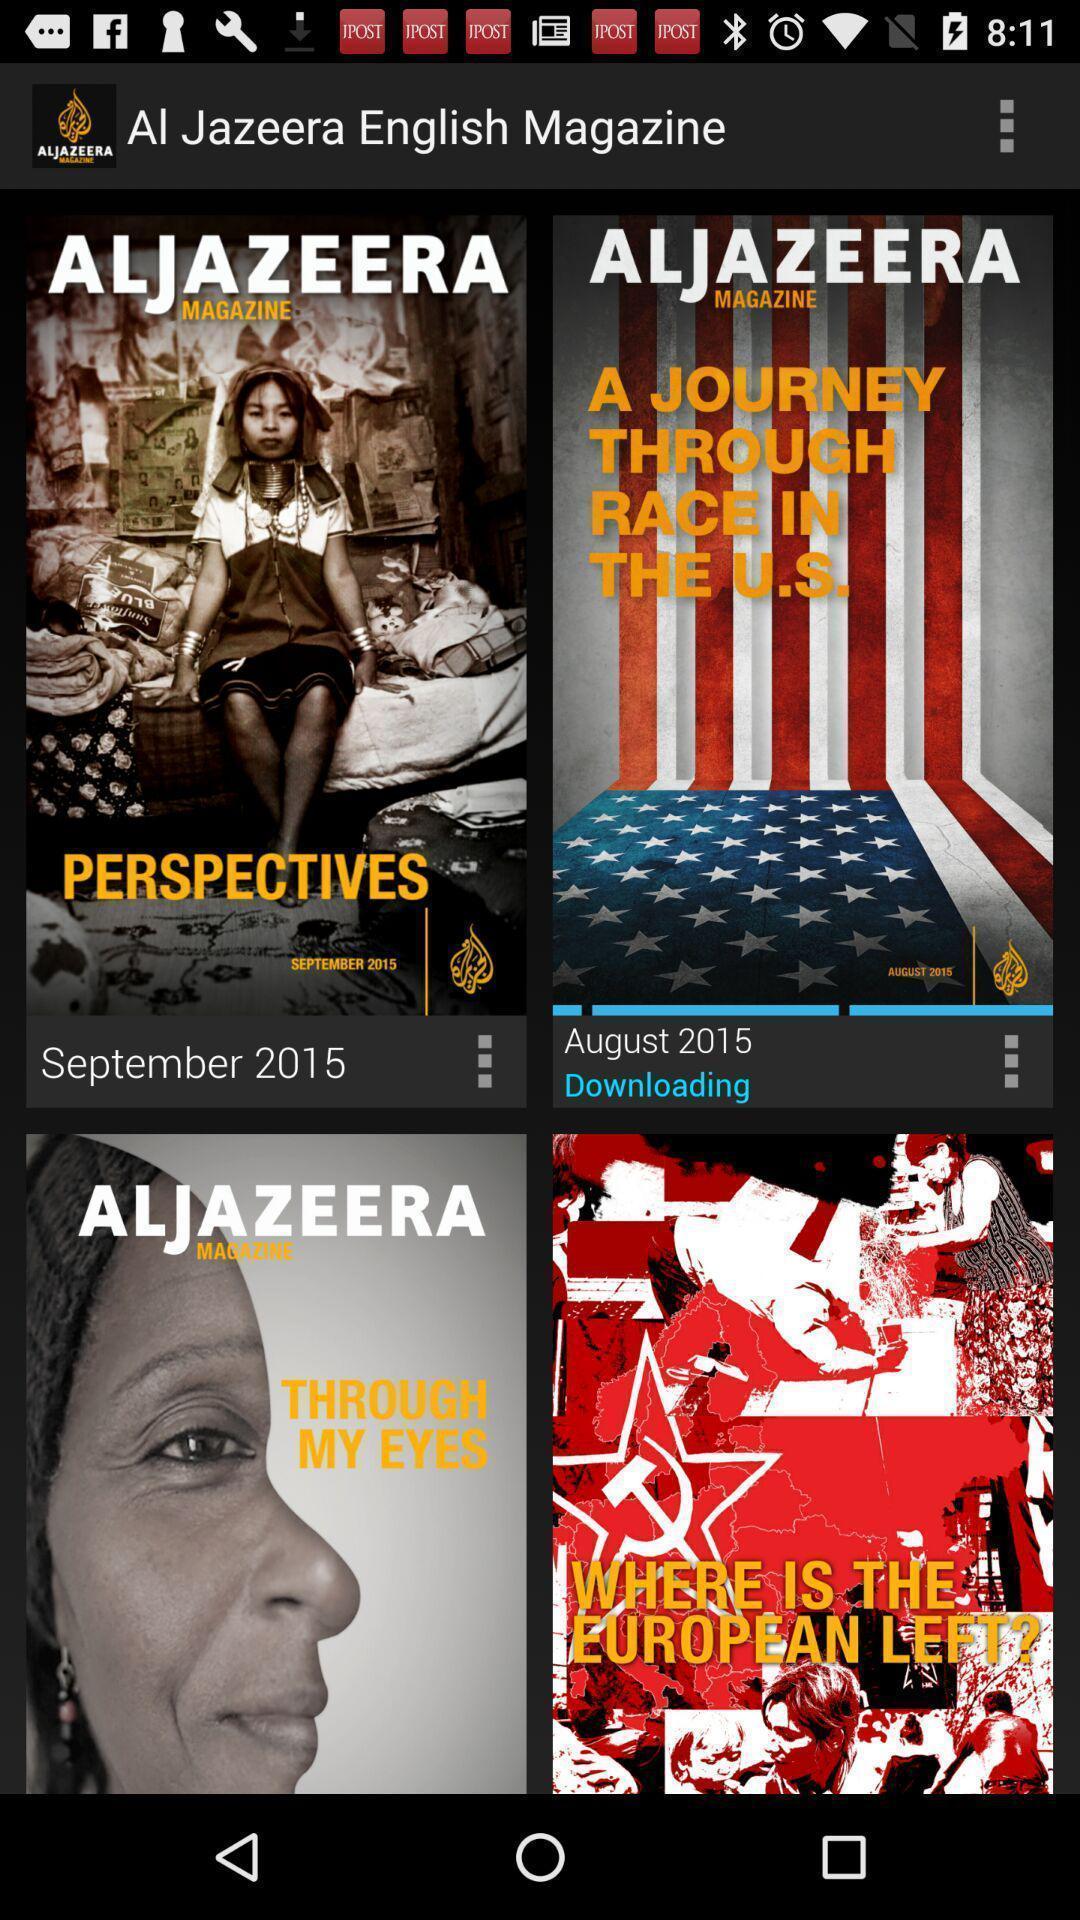Explain what's happening in this screen capture. Page with different magazines. 